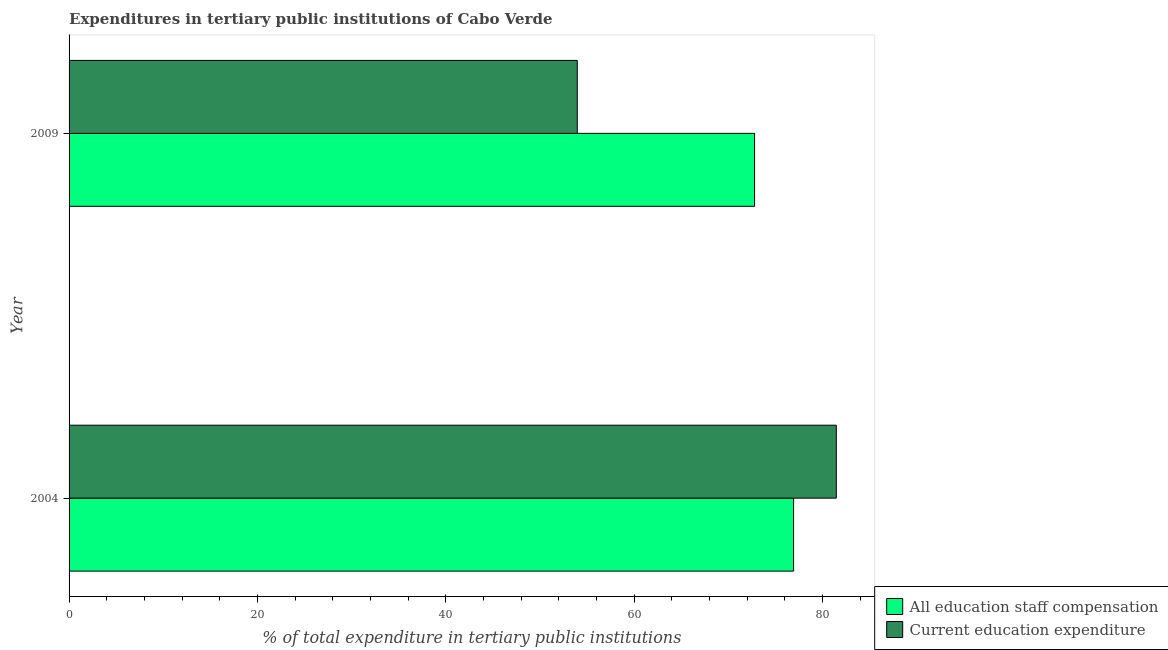How many groups of bars are there?
Give a very brief answer. 2. Are the number of bars per tick equal to the number of legend labels?
Make the answer very short. Yes. Are the number of bars on each tick of the Y-axis equal?
Keep it short and to the point. Yes. How many bars are there on the 1st tick from the bottom?
Keep it short and to the point. 2. What is the label of the 1st group of bars from the top?
Your answer should be very brief. 2009. What is the expenditure in education in 2009?
Give a very brief answer. 53.97. Across all years, what is the maximum expenditure in staff compensation?
Your answer should be compact. 76.94. Across all years, what is the minimum expenditure in education?
Your answer should be very brief. 53.97. In which year was the expenditure in staff compensation maximum?
Make the answer very short. 2004. In which year was the expenditure in staff compensation minimum?
Make the answer very short. 2009. What is the total expenditure in staff compensation in the graph?
Ensure brevity in your answer.  149.73. What is the difference between the expenditure in education in 2004 and that in 2009?
Make the answer very short. 27.51. What is the difference between the expenditure in education in 2004 and the expenditure in staff compensation in 2009?
Offer a terse response. 8.68. What is the average expenditure in staff compensation per year?
Provide a short and direct response. 74.87. In the year 2004, what is the difference between the expenditure in education and expenditure in staff compensation?
Keep it short and to the point. 4.54. What is the ratio of the expenditure in staff compensation in 2004 to that in 2009?
Offer a terse response. 1.06. What does the 1st bar from the top in 2004 represents?
Provide a succinct answer. Current education expenditure. What does the 1st bar from the bottom in 2004 represents?
Offer a very short reply. All education staff compensation. Are all the bars in the graph horizontal?
Ensure brevity in your answer.  Yes. How many years are there in the graph?
Your answer should be very brief. 2. What is the difference between two consecutive major ticks on the X-axis?
Provide a short and direct response. 20. Are the values on the major ticks of X-axis written in scientific E-notation?
Make the answer very short. No. Where does the legend appear in the graph?
Make the answer very short. Bottom right. How many legend labels are there?
Provide a short and direct response. 2. What is the title of the graph?
Keep it short and to the point. Expenditures in tertiary public institutions of Cabo Verde. What is the label or title of the X-axis?
Your answer should be compact. % of total expenditure in tertiary public institutions. What is the label or title of the Y-axis?
Your answer should be very brief. Year. What is the % of total expenditure in tertiary public institutions in All education staff compensation in 2004?
Your answer should be compact. 76.94. What is the % of total expenditure in tertiary public institutions of Current education expenditure in 2004?
Your response must be concise. 81.48. What is the % of total expenditure in tertiary public institutions of All education staff compensation in 2009?
Give a very brief answer. 72.8. What is the % of total expenditure in tertiary public institutions in Current education expenditure in 2009?
Ensure brevity in your answer.  53.97. Across all years, what is the maximum % of total expenditure in tertiary public institutions of All education staff compensation?
Provide a succinct answer. 76.94. Across all years, what is the maximum % of total expenditure in tertiary public institutions in Current education expenditure?
Your answer should be very brief. 81.48. Across all years, what is the minimum % of total expenditure in tertiary public institutions of All education staff compensation?
Make the answer very short. 72.8. Across all years, what is the minimum % of total expenditure in tertiary public institutions in Current education expenditure?
Offer a very short reply. 53.97. What is the total % of total expenditure in tertiary public institutions of All education staff compensation in the graph?
Provide a succinct answer. 149.73. What is the total % of total expenditure in tertiary public institutions of Current education expenditure in the graph?
Your answer should be very brief. 135.44. What is the difference between the % of total expenditure in tertiary public institutions in All education staff compensation in 2004 and that in 2009?
Provide a succinct answer. 4.14. What is the difference between the % of total expenditure in tertiary public institutions in Current education expenditure in 2004 and that in 2009?
Your answer should be very brief. 27.51. What is the difference between the % of total expenditure in tertiary public institutions of All education staff compensation in 2004 and the % of total expenditure in tertiary public institutions of Current education expenditure in 2009?
Provide a short and direct response. 22.97. What is the average % of total expenditure in tertiary public institutions of All education staff compensation per year?
Your response must be concise. 74.87. What is the average % of total expenditure in tertiary public institutions of Current education expenditure per year?
Your answer should be compact. 67.72. In the year 2004, what is the difference between the % of total expenditure in tertiary public institutions of All education staff compensation and % of total expenditure in tertiary public institutions of Current education expenditure?
Your answer should be compact. -4.54. In the year 2009, what is the difference between the % of total expenditure in tertiary public institutions in All education staff compensation and % of total expenditure in tertiary public institutions in Current education expenditure?
Keep it short and to the point. 18.83. What is the ratio of the % of total expenditure in tertiary public institutions of All education staff compensation in 2004 to that in 2009?
Provide a short and direct response. 1.06. What is the ratio of the % of total expenditure in tertiary public institutions of Current education expenditure in 2004 to that in 2009?
Give a very brief answer. 1.51. What is the difference between the highest and the second highest % of total expenditure in tertiary public institutions of All education staff compensation?
Your answer should be compact. 4.14. What is the difference between the highest and the second highest % of total expenditure in tertiary public institutions of Current education expenditure?
Your answer should be compact. 27.51. What is the difference between the highest and the lowest % of total expenditure in tertiary public institutions of All education staff compensation?
Make the answer very short. 4.14. What is the difference between the highest and the lowest % of total expenditure in tertiary public institutions in Current education expenditure?
Ensure brevity in your answer.  27.51. 